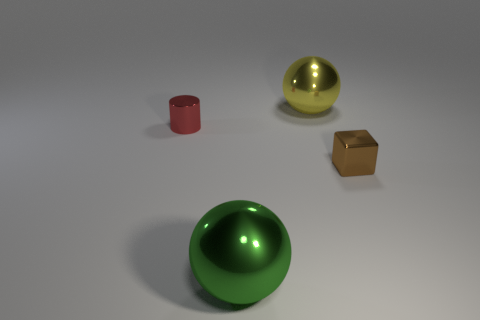Subtract all yellow balls. How many balls are left? 1 Add 2 objects. How many objects exist? 6 Subtract 1 spheres. How many spheres are left? 1 Subtract all cubes. How many objects are left? 3 Add 2 tiny cyan balls. How many tiny cyan balls exist? 2 Subtract 1 yellow balls. How many objects are left? 3 Subtract all green cylinders. Subtract all purple cubes. How many cylinders are left? 1 Subtract all big yellow metallic balls. Subtract all tiny brown cubes. How many objects are left? 2 Add 3 green balls. How many green balls are left? 4 